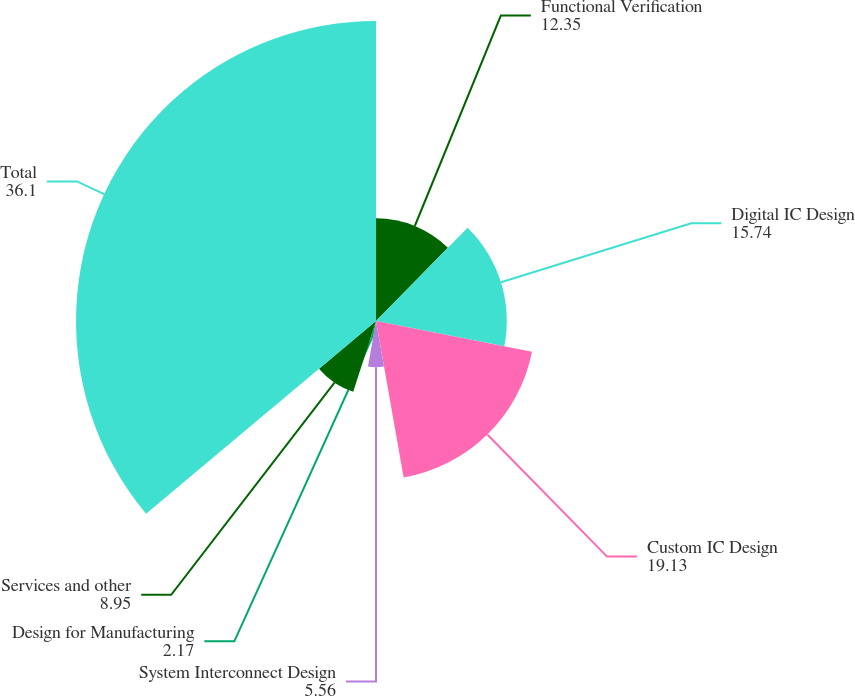Convert chart. <chart><loc_0><loc_0><loc_500><loc_500><pie_chart><fcel>Functional Verification<fcel>Digital IC Design<fcel>Custom IC Design<fcel>System Interconnect Design<fcel>Design for Manufacturing<fcel>Services and other<fcel>Total<nl><fcel>12.35%<fcel>15.74%<fcel>19.13%<fcel>5.56%<fcel>2.17%<fcel>8.95%<fcel>36.1%<nl></chart> 